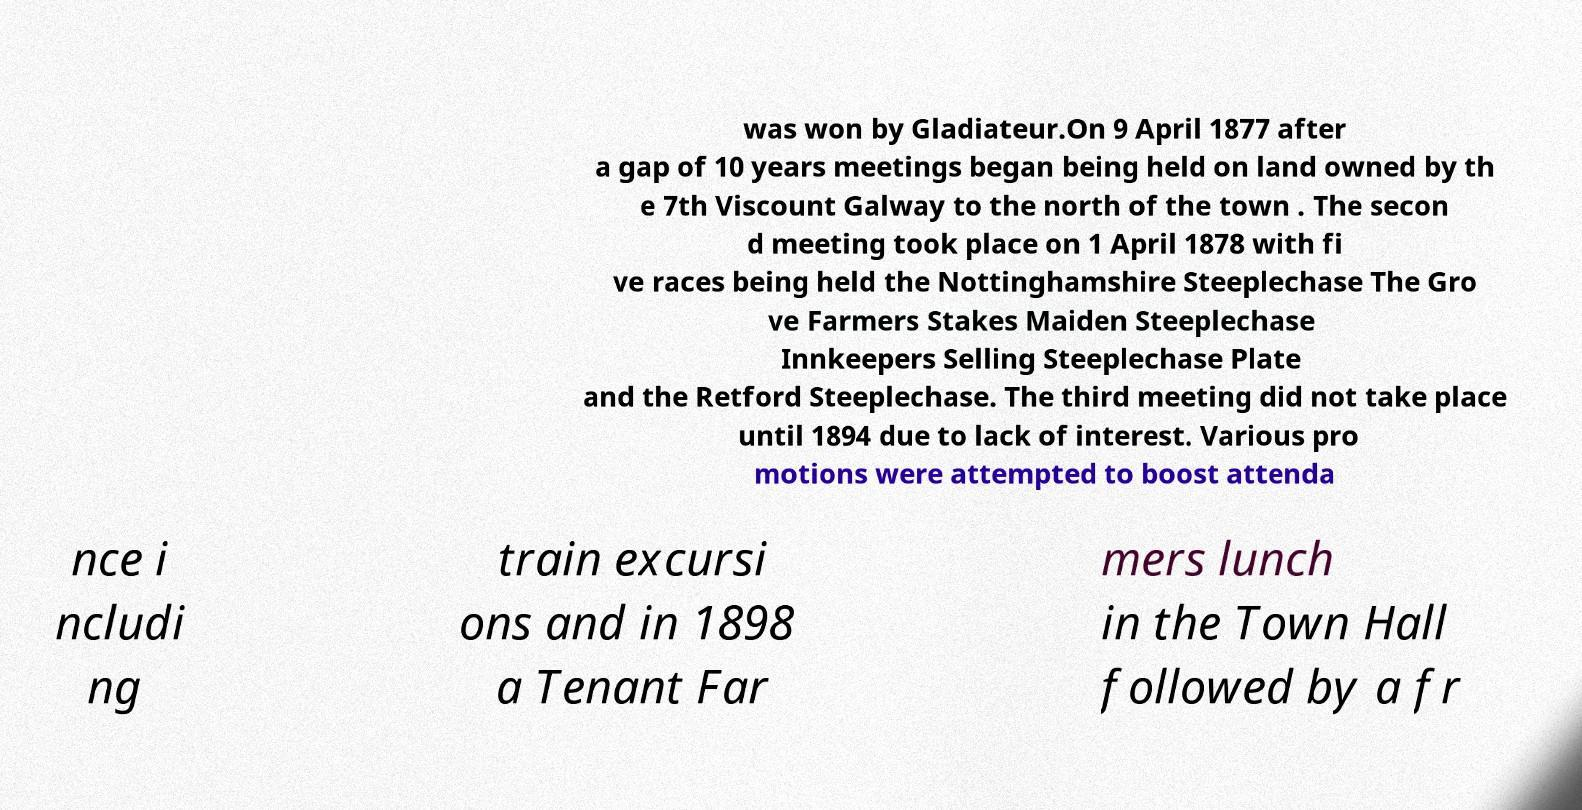Can you accurately transcribe the text from the provided image for me? was won by Gladiateur.On 9 April 1877 after a gap of 10 years meetings began being held on land owned by th e 7th Viscount Galway to the north of the town . The secon d meeting took place on 1 April 1878 with fi ve races being held the Nottinghamshire Steeplechase The Gro ve Farmers Stakes Maiden Steeplechase Innkeepers Selling Steeplechase Plate and the Retford Steeplechase. The third meeting did not take place until 1894 due to lack of interest. Various pro motions were attempted to boost attenda nce i ncludi ng train excursi ons and in 1898 a Tenant Far mers lunch in the Town Hall followed by a fr 